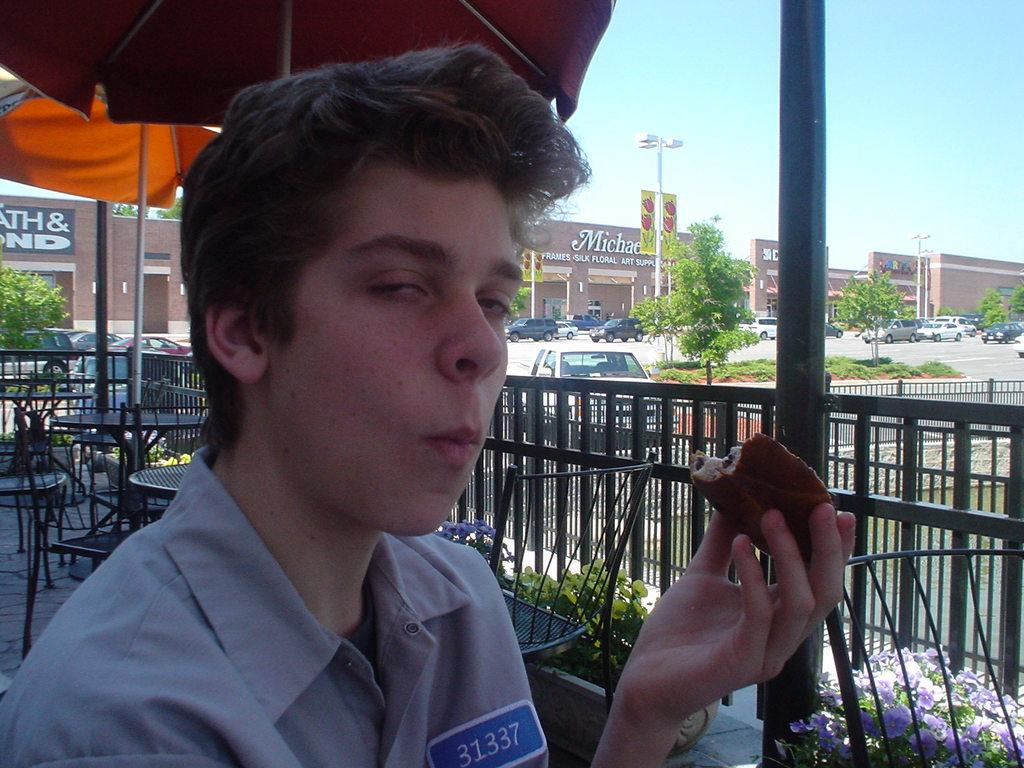<image>
Give a short and clear explanation of the subsequent image. Person eating something while wearing a tag that says 31337. 